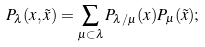Convert formula to latex. <formula><loc_0><loc_0><loc_500><loc_500>P _ { \lambda } ( x , \tilde { x } ) = \sum _ { \mu \subset \lambda } P _ { \lambda / \mu } ( x ) P _ { \mu } ( \tilde { x } ) ;</formula> 